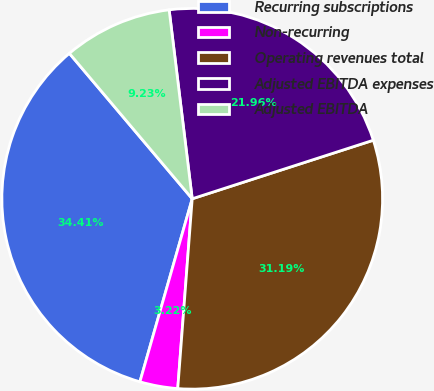<chart> <loc_0><loc_0><loc_500><loc_500><pie_chart><fcel>Recurring subscriptions<fcel>Non-recurring<fcel>Operating revenues total<fcel>Adjusted EBITDA expenses<fcel>Adjusted EBITDA<nl><fcel>34.41%<fcel>3.22%<fcel>31.19%<fcel>21.96%<fcel>9.23%<nl></chart> 